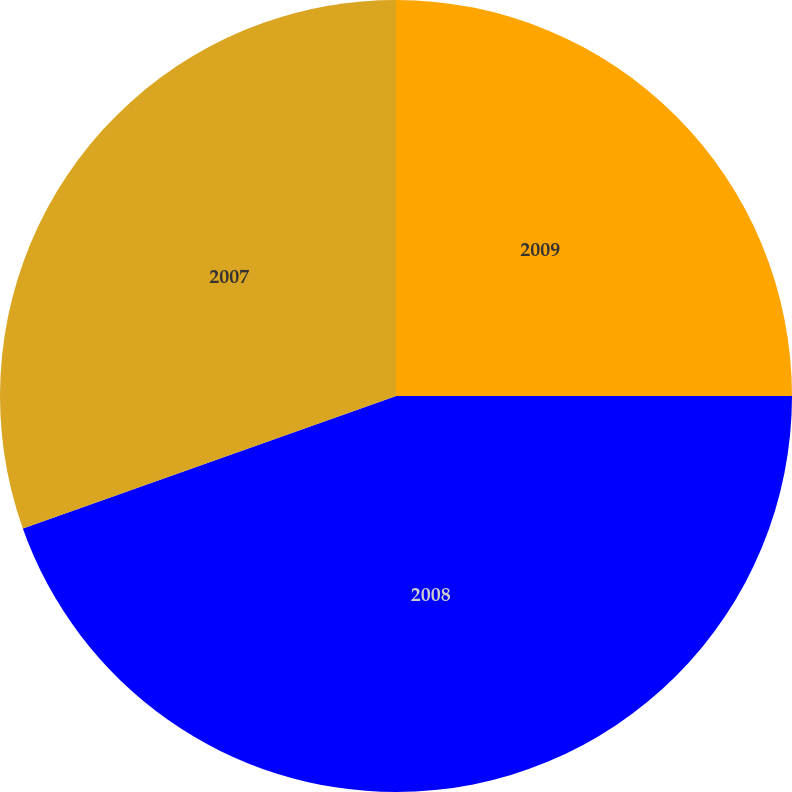Convert chart. <chart><loc_0><loc_0><loc_500><loc_500><pie_chart><fcel>2009<fcel>2008<fcel>2007<nl><fcel>25.0%<fcel>44.57%<fcel>30.43%<nl></chart> 